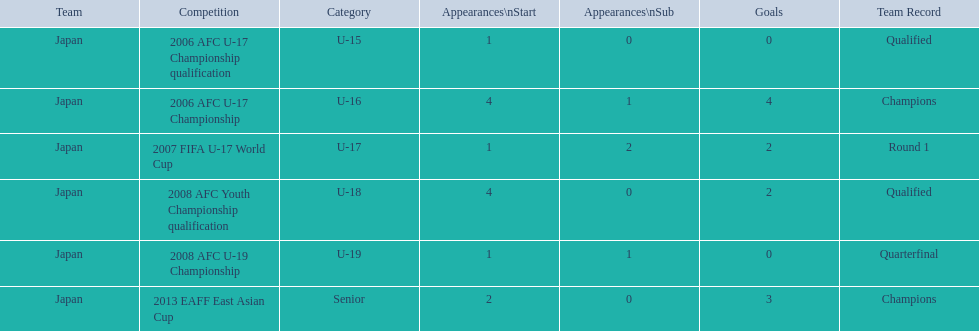What was the group's performance in 2006? Round 1. Which contest did this pertain to? 2006 AFC U-17 Championship. 